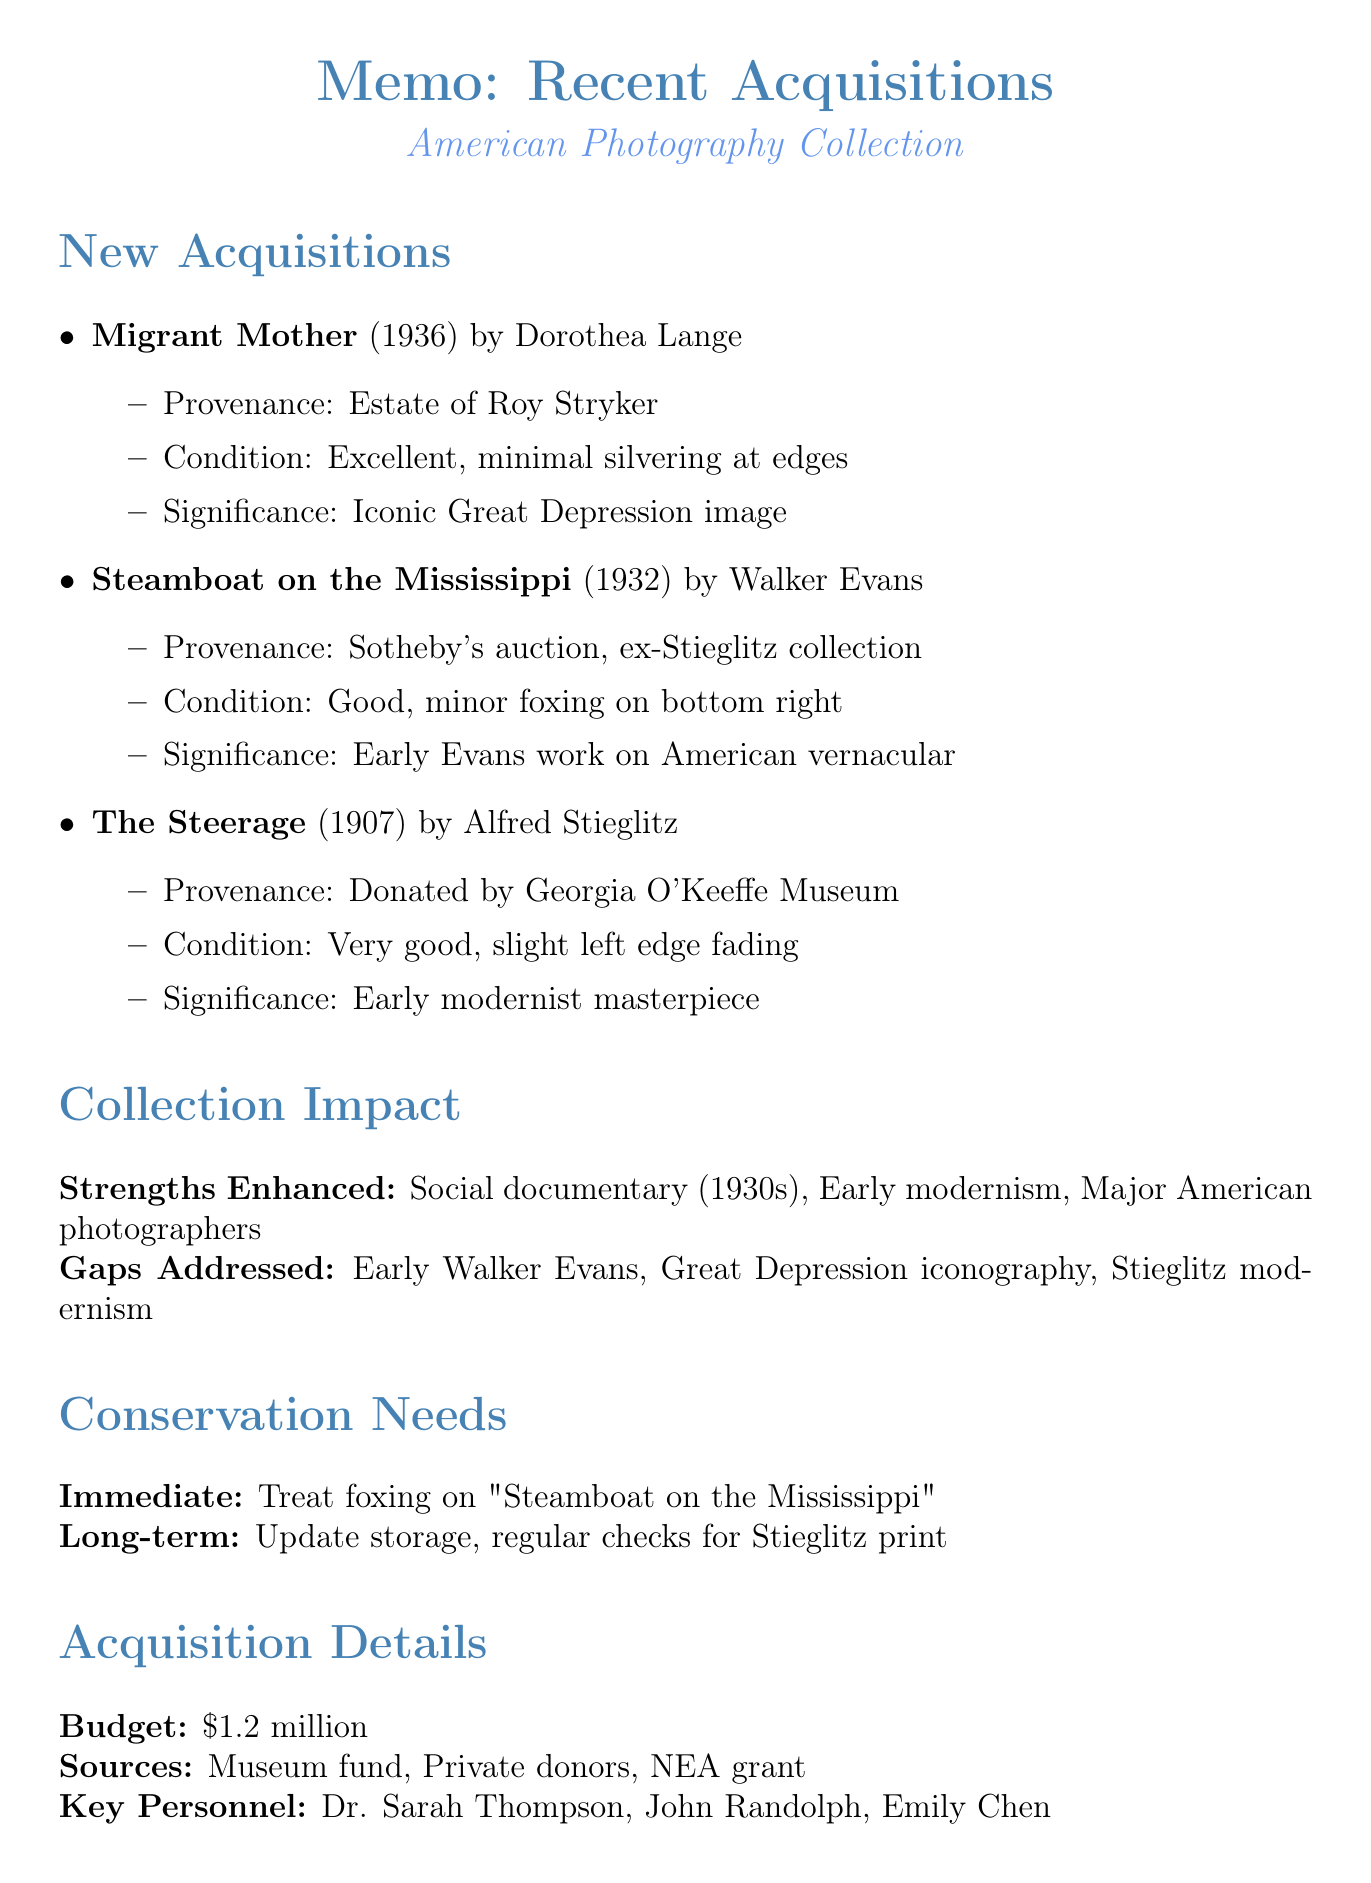What is the title of the photograph by Dorothea Lange? The title is mentioned under her entry in the acquisitions section.
Answer: Migrant Mother In what year was "The Steerage" created? The year of creation is specified next to the title in the document.
Answer: 1907 Who was the previous owner of "Steamboat on the Mississippi"? The provenance of the photograph provides details about its ownership history.
Answer: Alfred Stieglitz What condition is "Migrant Mother" reported to be in? The condition of the photograph is listed in its respective entry.
Answer: Excellent; minimal silvering at edges Which key personnel was involved in the acquisitions? The document lists important individuals in the acquisition process section.
Answer: Dr. Sarah Thompson What is one of the immediate conservation needs for the collection? Immediate actions required are detailed under conservation needs.
Answer: Treat foxing on "Steamboat on the Mississippi" What is the total budget utilized for acquisitions? The budget is explicitly stated in the acquisition details section.
Answer: $1.2 million Which theme should the future educational programs focus on? Future recommendations outline themes for educational programs.
Answer: Social documentary and modernist photography What gaps does the recent acquisition address according to the document? The document's collection impact section mentions the gaps that have been addressed.
Answer: Early work by Walker Evans 